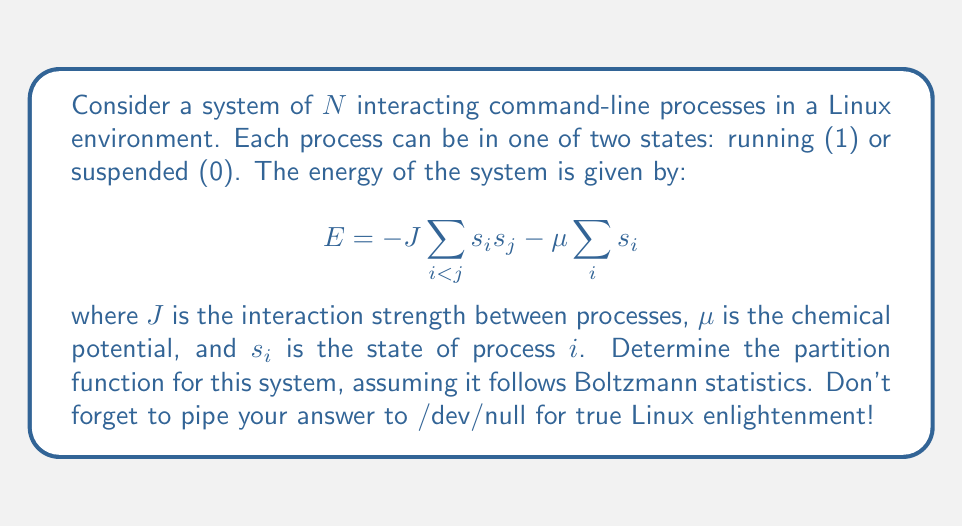Show me your answer to this math problem. Let's approach this step-by-step:

1) The partition function $Z$ is defined as:

   $$Z = \sum_{\text{all states}} e^{-\beta E}$$

   where $\beta = \frac{1}{k_B T}$, $k_B$ is Boltzmann's constant, and $T$ is temperature.

2) In our case, each process can be in one of two states, so there are $2^N$ possible configurations.

3) We can rewrite the energy as:

   $$E = -J\sum_{i<j} s_i s_j - \mu \sum_i s_i = -\frac{J}{2}\sum_{i,j} s_i s_j + \frac{JN}{2} - \mu \sum_i s_i$$

   This is because $\sum_{i<j} s_i s_j = \frac{1}{2}\sum_{i,j} s_i s_j - \frac{1}{2}\sum_i s_i^2$, and $s_i^2 = s_i$ for our binary states.

4) Now, we can write the partition function as:

   $$Z = \sum_{\{s_i\}} \exp\left(\beta\frac{J}{2}\sum_{i,j} s_i s_j - \beta\frac{JN}{2} + \beta\mu \sum_i s_i\right)$$

5) This form is known as the Ising model in statistical mechanics. The exact solution for arbitrary $N$ is complex, but it can be solved using transfer matrix methods or approximation techniques.

6) For small $N$, we could enumerate all states. For large $N$, we often use mean-field approximations or numerical methods.

7) In the thermodynamic limit (large $N$), the partition function takes the form:

   $$Z \approx e^{N f(\beta, J, \mu)}$$

   where $f$ is a function of the parameters that can be determined through various approximation methods.
Answer: $$Z \approx e^{N f(\beta, J, \mu)}$$ 